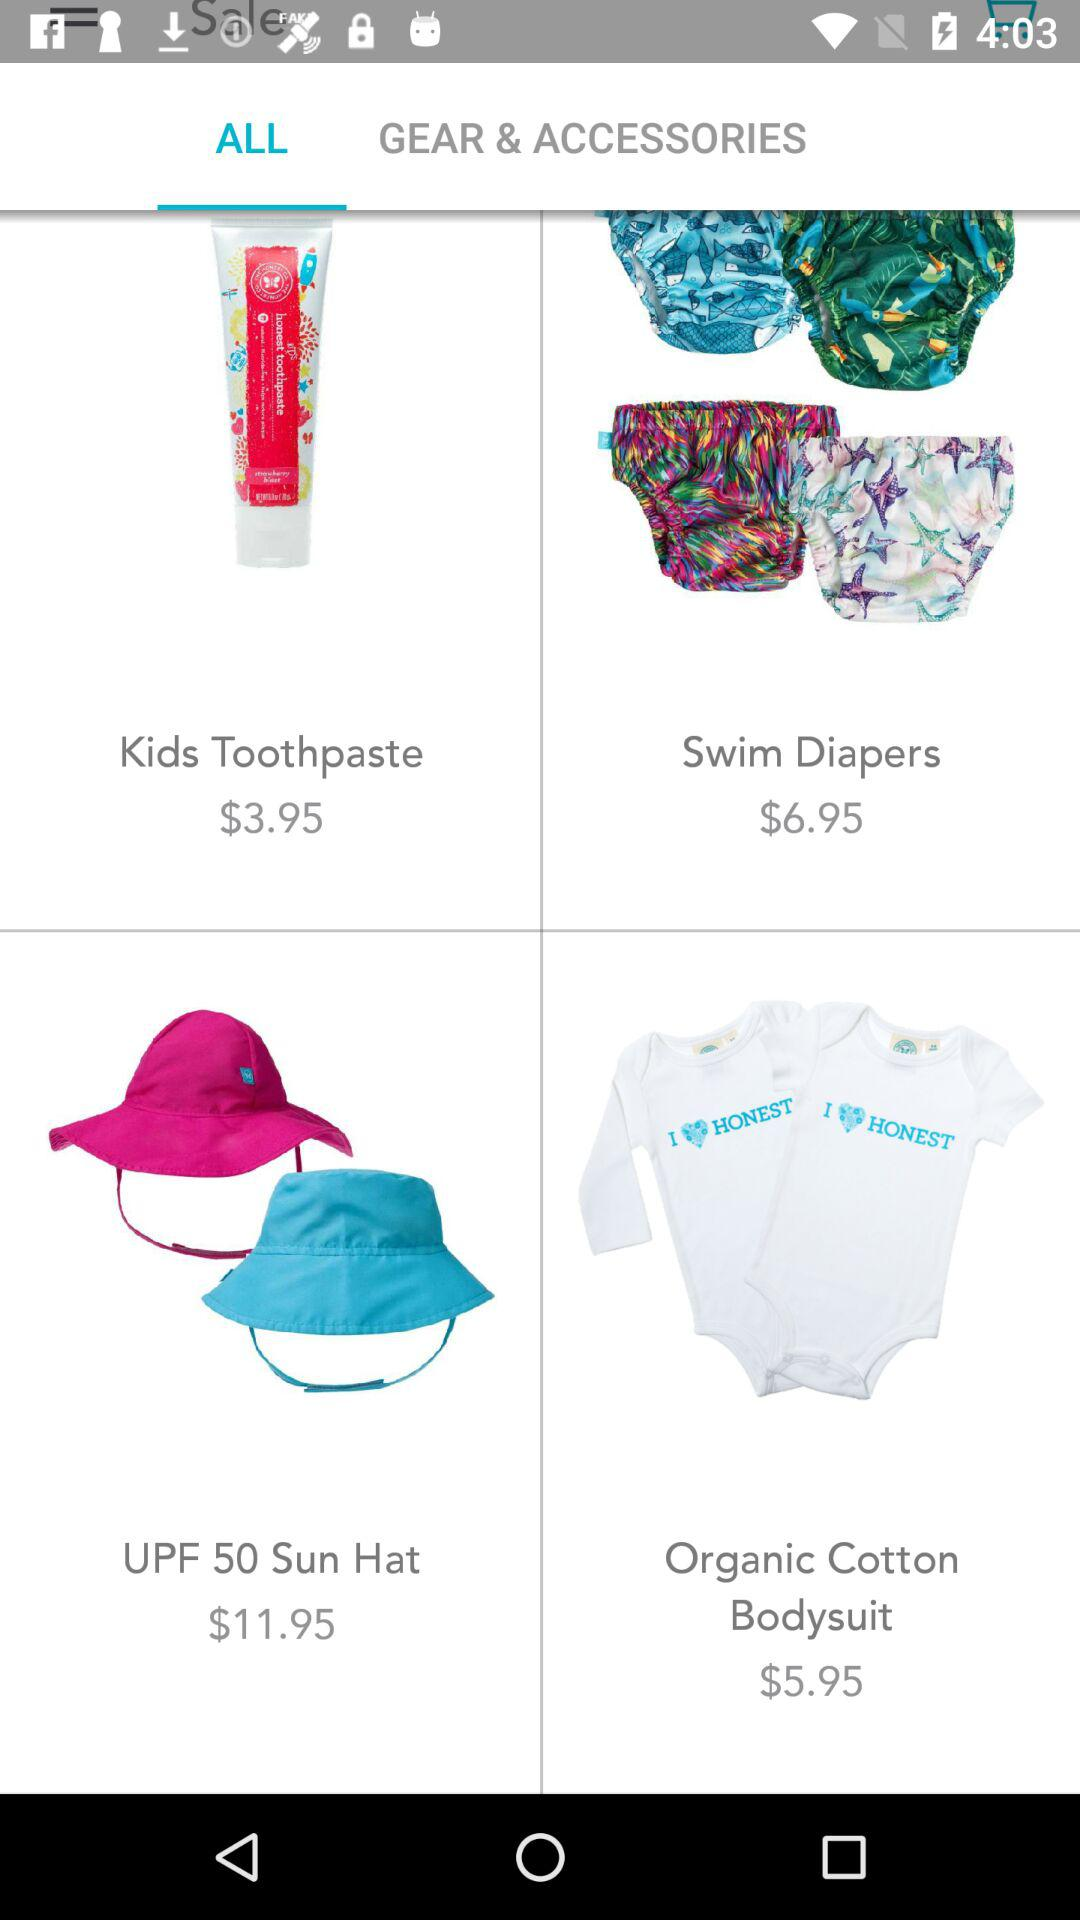What is the price of swim diapers? The price is $6.95. 